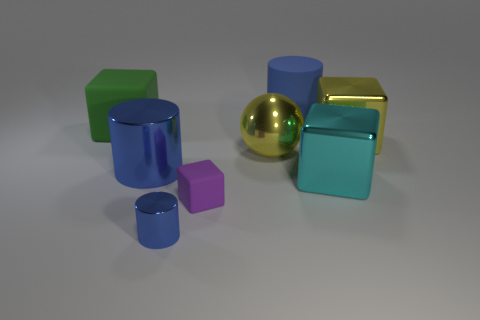How many blue cylinders must be subtracted to get 2 blue cylinders? 1 Subtract all yellow shiny blocks. How many blocks are left? 3 Subtract all yellow blocks. How many blocks are left? 3 Add 1 tiny gray blocks. How many objects exist? 9 Subtract all balls. How many objects are left? 7 Subtract 2 cylinders. How many cylinders are left? 1 Subtract all tiny rubber cubes. Subtract all tiny gray metal cylinders. How many objects are left? 7 Add 1 metal things. How many metal things are left? 6 Add 1 yellow balls. How many yellow balls exist? 2 Subtract 0 red balls. How many objects are left? 8 